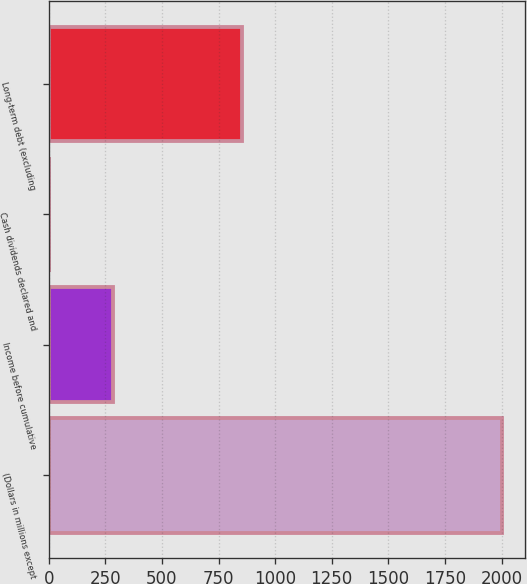<chart> <loc_0><loc_0><loc_500><loc_500><bar_chart><fcel>(Dollars in millions except<fcel>Income before cumulative<fcel>Cash dividends declared and<fcel>Long-term debt (excluding<nl><fcel>2004<fcel>285.4<fcel>1.44<fcel>853.32<nl></chart> 